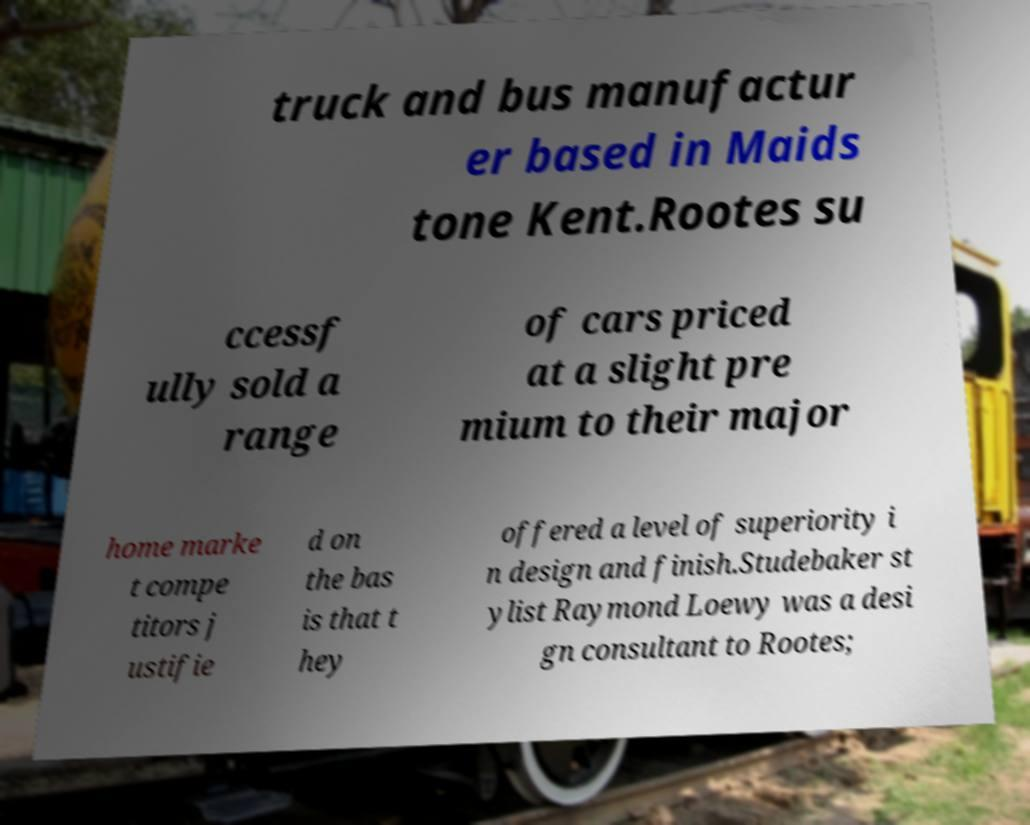Can you accurately transcribe the text from the provided image for me? truck and bus manufactur er based in Maids tone Kent.Rootes su ccessf ully sold a range of cars priced at a slight pre mium to their major home marke t compe titors j ustifie d on the bas is that t hey offered a level of superiority i n design and finish.Studebaker st ylist Raymond Loewy was a desi gn consultant to Rootes; 